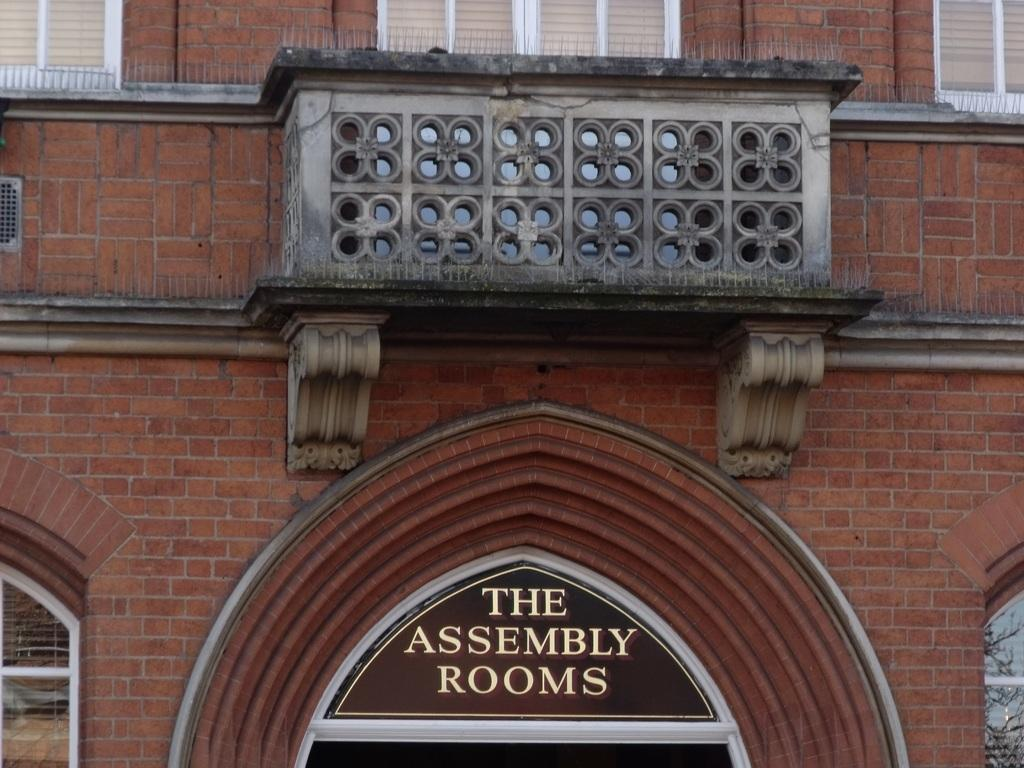What is the main structure in the picture? There is a building in the picture. What feature can be found at the bottom of the building? There are windows at the bottom of the building. What is written or displayed on the windows at the bottom? There is text associated with the windows at the bottom. What can be seen in the center of the picture? There is railing in the center of the picture. What feature can be found at the top of the building? There are windows at the top of the building. Can you tell me how many giraffes are standing on the railing in the image? There are no giraffes present in the image; the railing is not associated with any animals. What type of wool is used to make the text on the windows at the bottom? There is no wool mentioned or visible in the image; the text is likely printed or painted on the windows. 